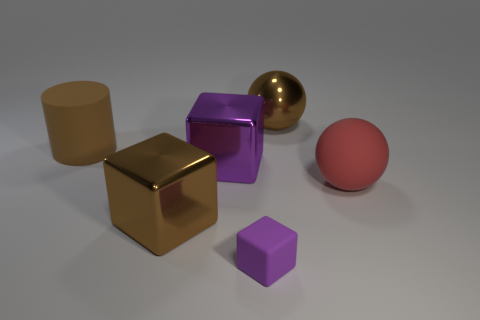Subtract all cyan blocks. Subtract all cyan cylinders. How many blocks are left? 3 Add 2 large brown matte cylinders. How many objects exist? 8 Subtract all cylinders. How many objects are left? 5 Subtract 0 blue cylinders. How many objects are left? 6 Subtract all big red spheres. Subtract all purple things. How many objects are left? 3 Add 3 small cubes. How many small cubes are left? 4 Add 1 big balls. How many big balls exist? 3 